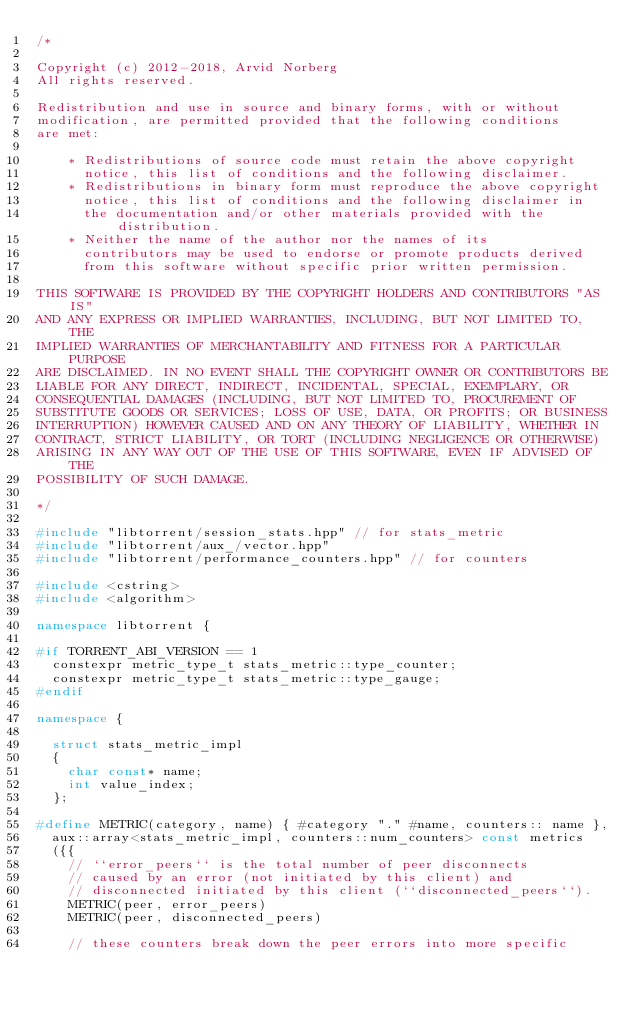Convert code to text. <code><loc_0><loc_0><loc_500><loc_500><_C++_>/*

Copyright (c) 2012-2018, Arvid Norberg
All rights reserved.

Redistribution and use in source and binary forms, with or without
modification, are permitted provided that the following conditions
are met:

    * Redistributions of source code must retain the above copyright
      notice, this list of conditions and the following disclaimer.
    * Redistributions in binary form must reproduce the above copyright
      notice, this list of conditions and the following disclaimer in
      the documentation and/or other materials provided with the distribution.
    * Neither the name of the author nor the names of its
      contributors may be used to endorse or promote products derived
      from this software without specific prior written permission.

THIS SOFTWARE IS PROVIDED BY THE COPYRIGHT HOLDERS AND CONTRIBUTORS "AS IS"
AND ANY EXPRESS OR IMPLIED WARRANTIES, INCLUDING, BUT NOT LIMITED TO, THE
IMPLIED WARRANTIES OF MERCHANTABILITY AND FITNESS FOR A PARTICULAR PURPOSE
ARE DISCLAIMED. IN NO EVENT SHALL THE COPYRIGHT OWNER OR CONTRIBUTORS BE
LIABLE FOR ANY DIRECT, INDIRECT, INCIDENTAL, SPECIAL, EXEMPLARY, OR
CONSEQUENTIAL DAMAGES (INCLUDING, BUT NOT LIMITED TO, PROCUREMENT OF
SUBSTITUTE GOODS OR SERVICES; LOSS OF USE, DATA, OR PROFITS; OR BUSINESS
INTERRUPTION) HOWEVER CAUSED AND ON ANY THEORY OF LIABILITY, WHETHER IN
CONTRACT, STRICT LIABILITY, OR TORT (INCLUDING NEGLIGENCE OR OTHERWISE)
ARISING IN ANY WAY OUT OF THE USE OF THIS SOFTWARE, EVEN IF ADVISED OF THE
POSSIBILITY OF SUCH DAMAGE.

*/

#include "libtorrent/session_stats.hpp" // for stats_metric
#include "libtorrent/aux_/vector.hpp"
#include "libtorrent/performance_counters.hpp" // for counters

#include <cstring>
#include <algorithm>

namespace libtorrent {

#if TORRENT_ABI_VERSION == 1
	constexpr metric_type_t stats_metric::type_counter;
	constexpr metric_type_t stats_metric::type_gauge;
#endif

namespace {

	struct stats_metric_impl
	{
		char const* name;
		int value_index;
	};

#define METRIC(category, name) { #category "." #name, counters:: name },
	aux::array<stats_metric_impl, counters::num_counters> const metrics
	({{
		// ``error_peers`` is the total number of peer disconnects
		// caused by an error (not initiated by this client) and
		// disconnected initiated by this client (``disconnected_peers``).
		METRIC(peer, error_peers)
		METRIC(peer, disconnected_peers)

		// these counters break down the peer errors into more specific</code> 